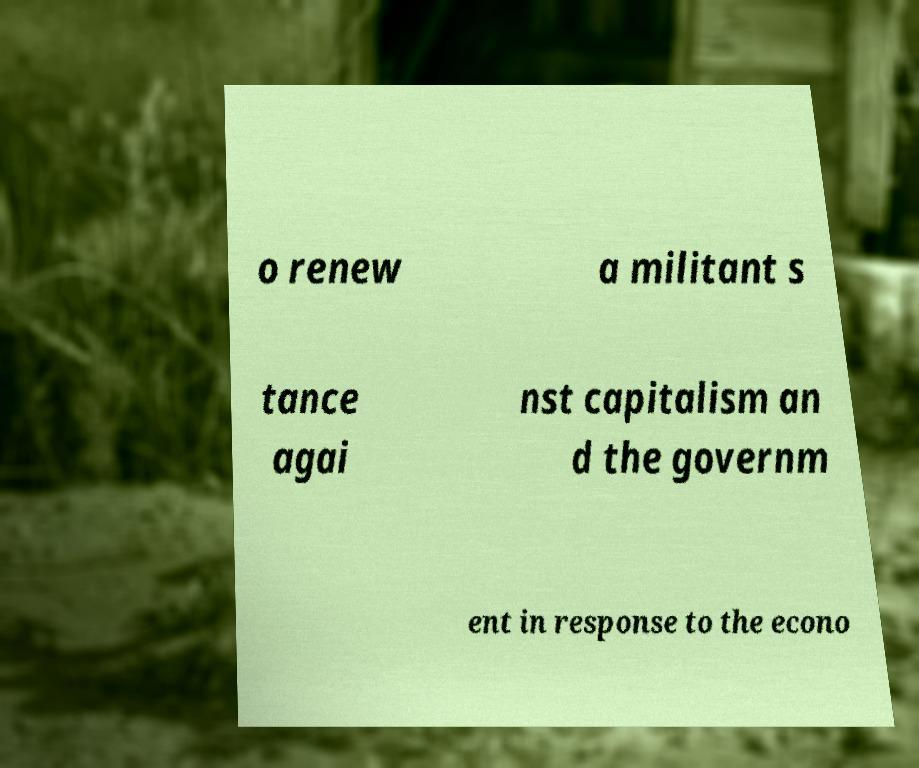Could you extract and type out the text from this image? o renew a militant s tance agai nst capitalism an d the governm ent in response to the econo 